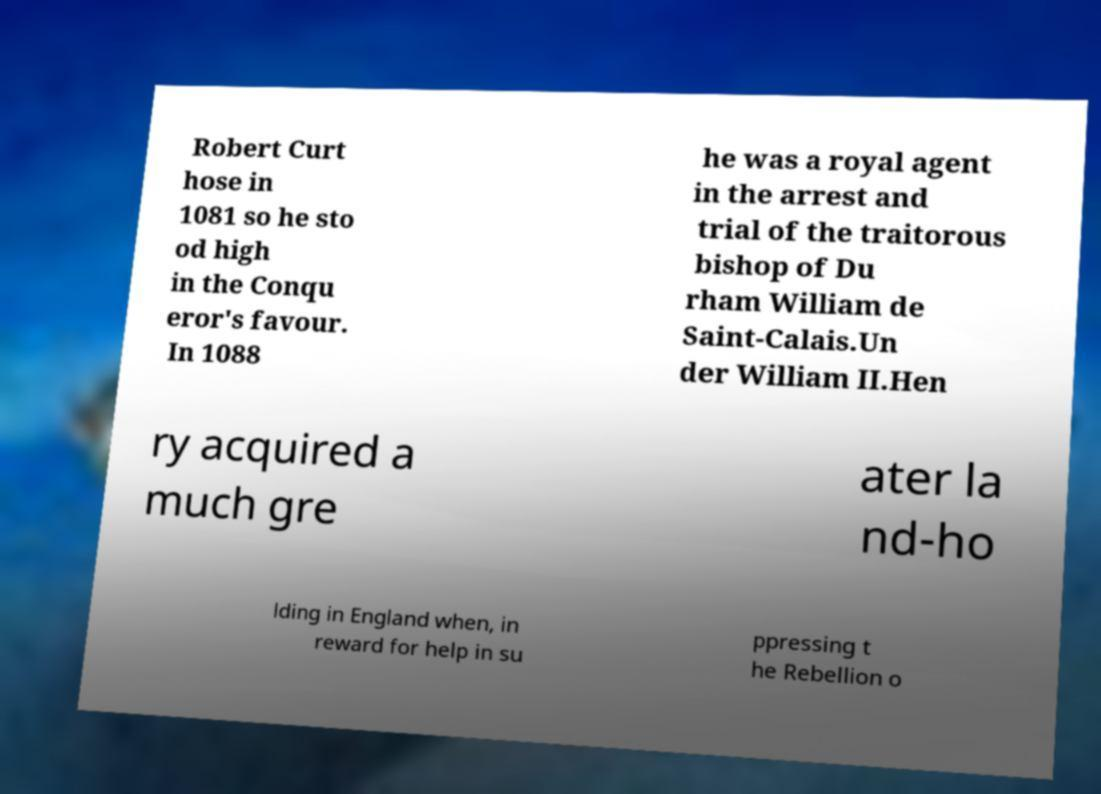There's text embedded in this image that I need extracted. Can you transcribe it verbatim? Robert Curt hose in 1081 so he sto od high in the Conqu eror's favour. In 1088 he was a royal agent in the arrest and trial of the traitorous bishop of Du rham William de Saint-Calais.Un der William II.Hen ry acquired a much gre ater la nd-ho lding in England when, in reward for help in su ppressing t he Rebellion o 